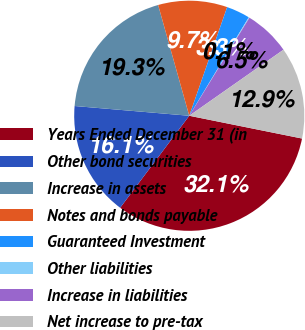Convert chart. <chart><loc_0><loc_0><loc_500><loc_500><pie_chart><fcel>Years Ended December 31 (in<fcel>Other bond securities<fcel>Increase in assets<fcel>Notes and bonds payable<fcel>Guaranteed Investment<fcel>Other liabilities<fcel>Increase in liabilities<fcel>Net increase to pre-tax<nl><fcel>32.08%<fcel>16.1%<fcel>19.29%<fcel>9.7%<fcel>3.31%<fcel>0.11%<fcel>6.51%<fcel>12.9%<nl></chart> 